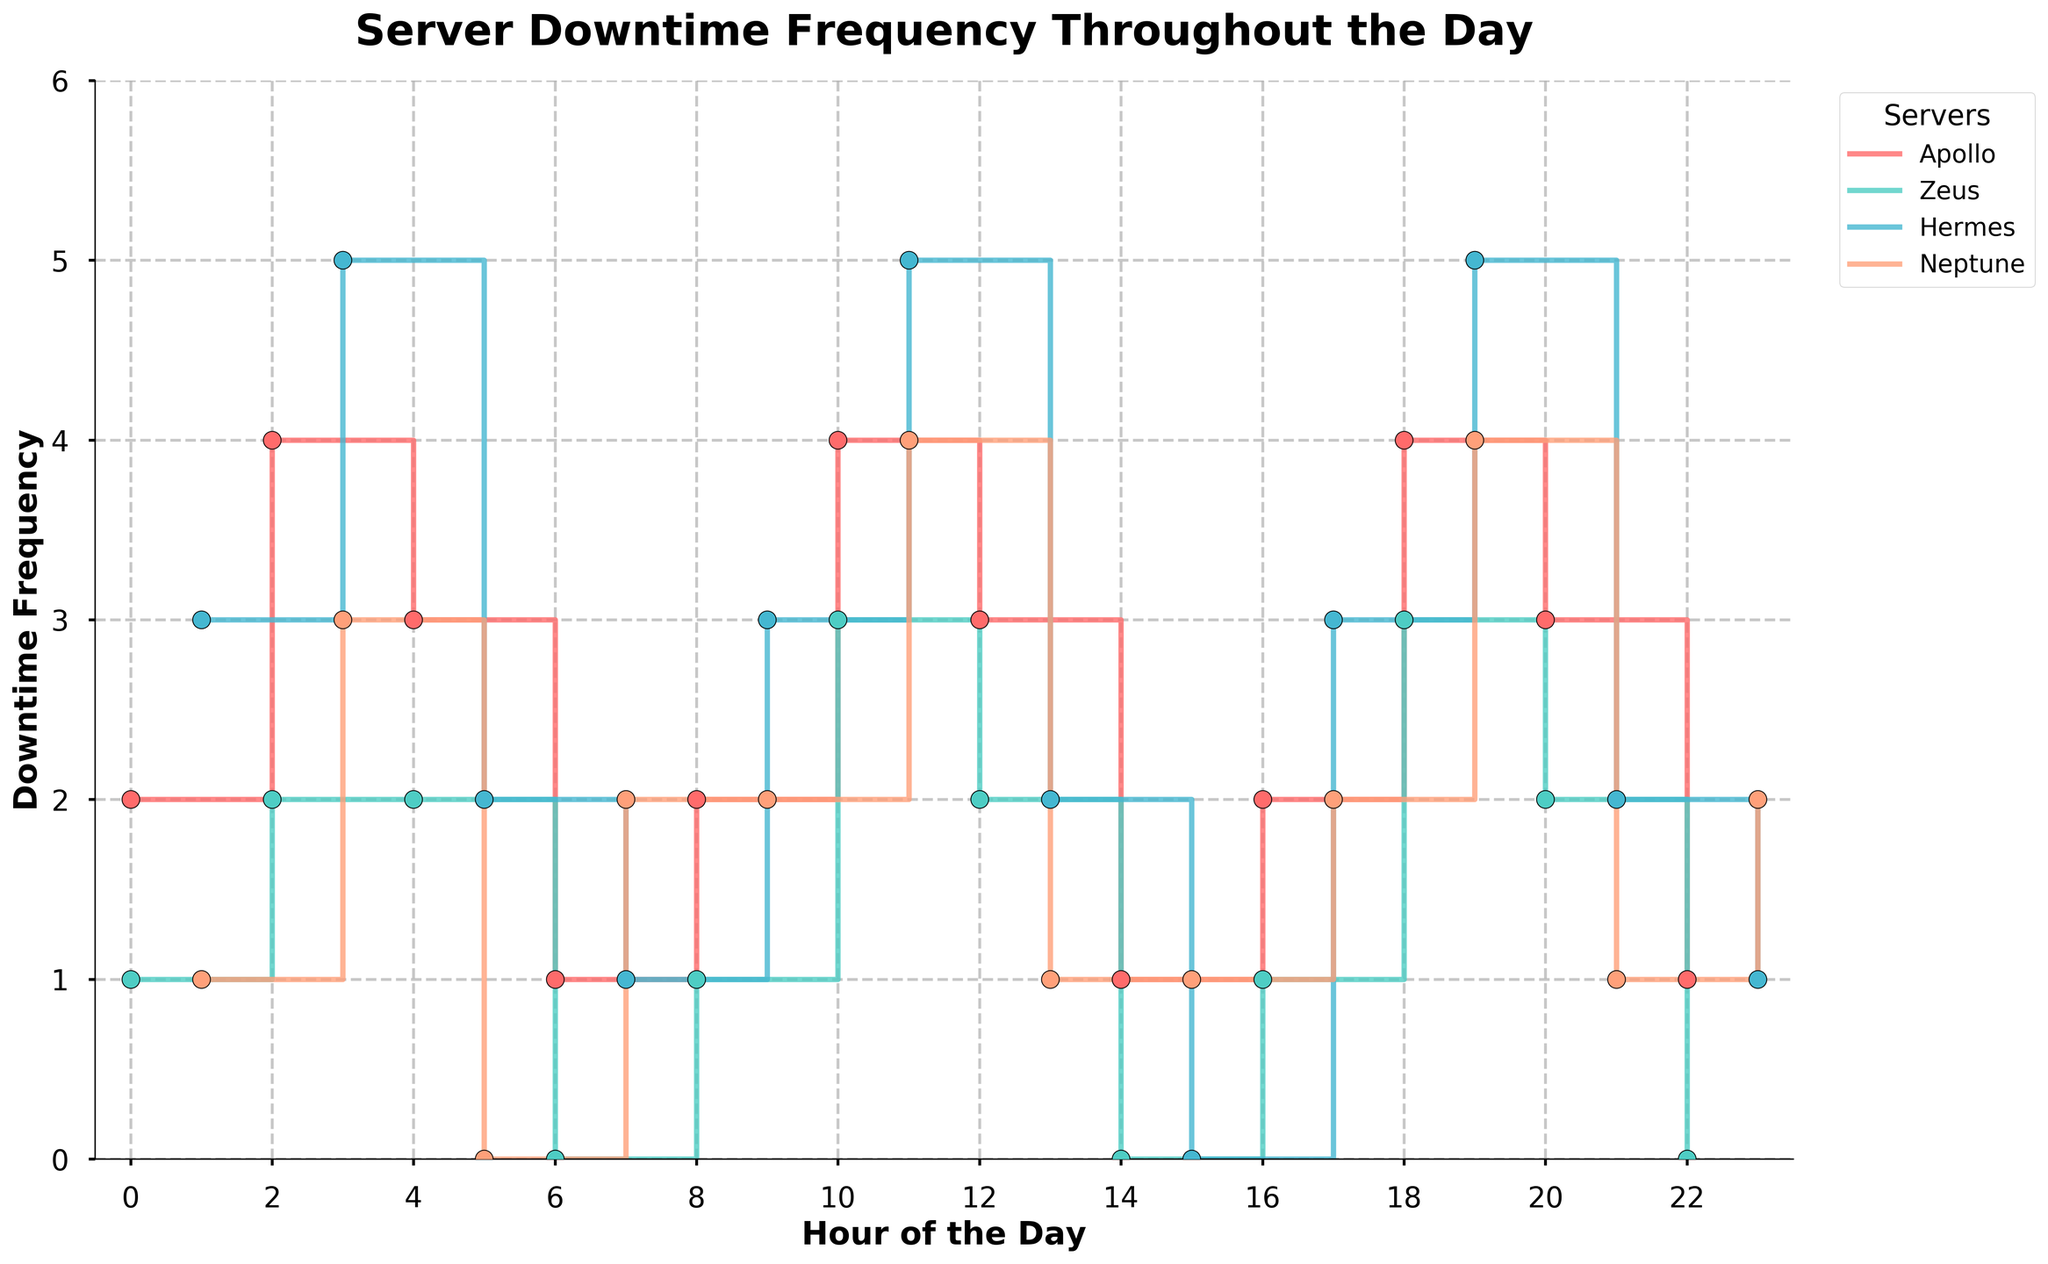What is the title of the plot? The title of the plot is displayed at the top center of the figure, and it reads "Server Downtime Frequency Throughout the Day"
Answer: Server Downtime Frequency Throughout the Day How many servers are displayed in the plot? The plot shows lines and legends for each server. By counting the unique labels in the legend, you can see there are four servers.
Answer: Four What are the colors used to represent each server in the plot? Each server is represented by a distinct color in the plot and legend. By looking at the legend: Apollo is red, Zeus is green, Hermes is blue, Neptune is orange.
Answer: Red, Green, Blue, Orange Which server had the highest downtime frequency at 19:00? By looking at the value on the vertical axis for the respective server at the 19:00 mark, Hermes has the highest downtime frequency of 5.
Answer: Hermes What is the average downtime frequency for Apollo between 0:00 and 23:00? Sum all the downtime frequencies for Apollo, then divide by the number of hours: (2 + 4 + 3 + 1 + 2 + 4 + 3 + 1 + 2 + 4 + 3 + 1) / 12 = 30 / 12 = 2.5
Answer: 2.5 During which hours did Neptune have zero downtimes? By examining where Neptune's plot line touches the x-axis, Neptune had zero downtimes at 5:00, 6:00, 14:00, and 22:00.
Answer: 5:00, 6:00, 14:00, 22:00 Which server shows the most variability in downtime frequency throughout the day? Hermes has the widest range from 0 to 5, while others like Neptune ranged between 0 to 4. The larger the range, the higher the variability.
Answer: Hermes How does the downtime frequency at 10:00 compare between Apollo and Zeus? At 10:00, Apollo has a downtime frequency of 4 while Zeus has a downtime frequency of 3. Comparing these values, Apollo has a higher downtime frequency.
Answer: Apollo What is the total downtime frequency for Zeus over the 24-hour period? Sum all the downtime frequencies for Zeus: 1 + 2 + 2 + 0 + 1 + 2 + 3 + 1 + 2 + 1 = 15
Answer: 15 Which server had the most downtime at 3:00? By examining the values at the 3:00 timestep, Hermes had the highest downtime frequency with a value of 5.
Answer: Hermes 